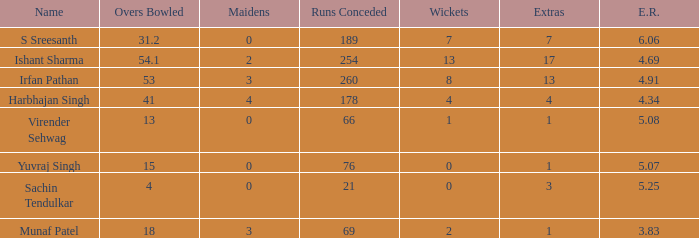2 overs are bowled? S Sreesanth. 